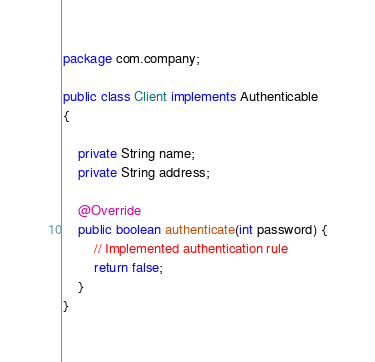<code> <loc_0><loc_0><loc_500><loc_500><_Java_>package com.company;

public class Client implements Authenticable
{
    
    private String name;
    private String address;

    @Override
    public boolean authenticate(int password) {
        // Implemented authentication rule
        return false;
    }
}</code> 